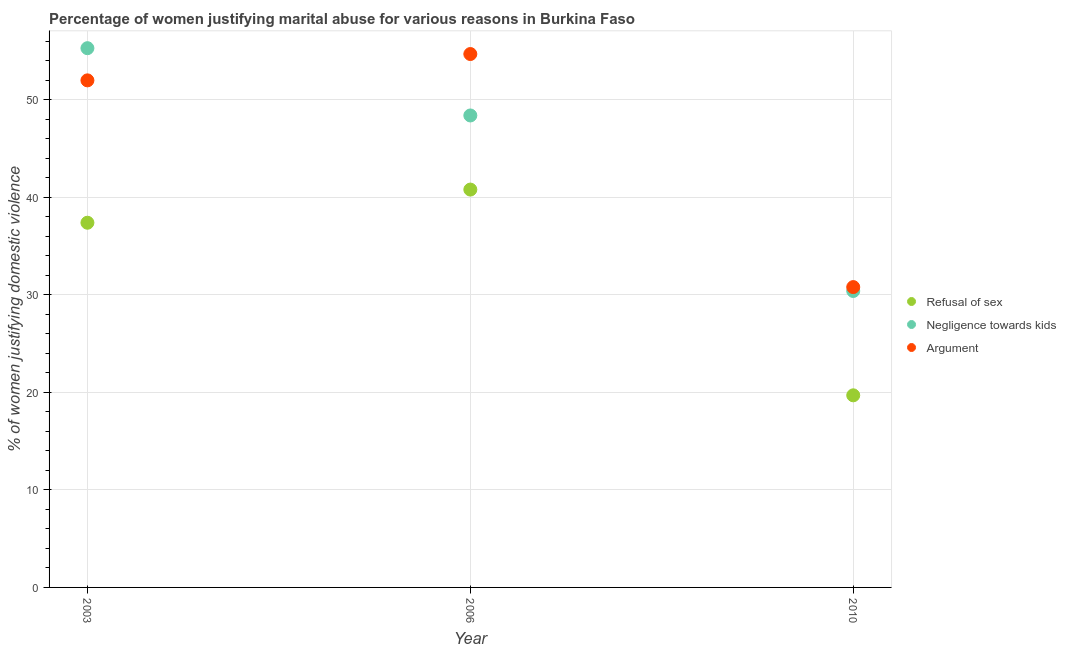How many different coloured dotlines are there?
Ensure brevity in your answer.  3. Is the number of dotlines equal to the number of legend labels?
Give a very brief answer. Yes. What is the percentage of women justifying domestic violence due to negligence towards kids in 2003?
Offer a terse response. 55.3. Across all years, what is the maximum percentage of women justifying domestic violence due to negligence towards kids?
Your answer should be very brief. 55.3. Across all years, what is the minimum percentage of women justifying domestic violence due to negligence towards kids?
Provide a short and direct response. 30.4. In which year was the percentage of women justifying domestic violence due to arguments maximum?
Provide a short and direct response. 2006. In which year was the percentage of women justifying domestic violence due to negligence towards kids minimum?
Ensure brevity in your answer.  2010. What is the total percentage of women justifying domestic violence due to negligence towards kids in the graph?
Your answer should be compact. 134.1. What is the difference between the percentage of women justifying domestic violence due to refusal of sex in 2006 and that in 2010?
Provide a short and direct response. 21.1. What is the difference between the percentage of women justifying domestic violence due to refusal of sex in 2003 and the percentage of women justifying domestic violence due to arguments in 2010?
Your answer should be compact. 6.6. What is the average percentage of women justifying domestic violence due to negligence towards kids per year?
Ensure brevity in your answer.  44.7. In the year 2006, what is the difference between the percentage of women justifying domestic violence due to negligence towards kids and percentage of women justifying domestic violence due to refusal of sex?
Make the answer very short. 7.6. What is the ratio of the percentage of women justifying domestic violence due to refusal of sex in 2006 to that in 2010?
Offer a terse response. 2.07. Is the percentage of women justifying domestic violence due to refusal of sex in 2006 less than that in 2010?
Keep it short and to the point. No. Is the difference between the percentage of women justifying domestic violence due to arguments in 2003 and 2010 greater than the difference between the percentage of women justifying domestic violence due to refusal of sex in 2003 and 2010?
Offer a very short reply. Yes. What is the difference between the highest and the second highest percentage of women justifying domestic violence due to refusal of sex?
Provide a short and direct response. 3.4. What is the difference between the highest and the lowest percentage of women justifying domestic violence due to refusal of sex?
Offer a terse response. 21.1. In how many years, is the percentage of women justifying domestic violence due to negligence towards kids greater than the average percentage of women justifying domestic violence due to negligence towards kids taken over all years?
Offer a very short reply. 2. Is the sum of the percentage of women justifying domestic violence due to arguments in 2006 and 2010 greater than the maximum percentage of women justifying domestic violence due to negligence towards kids across all years?
Give a very brief answer. Yes. Is it the case that in every year, the sum of the percentage of women justifying domestic violence due to refusal of sex and percentage of women justifying domestic violence due to negligence towards kids is greater than the percentage of women justifying domestic violence due to arguments?
Keep it short and to the point. Yes. Is the percentage of women justifying domestic violence due to arguments strictly greater than the percentage of women justifying domestic violence due to negligence towards kids over the years?
Make the answer very short. No. How many dotlines are there?
Make the answer very short. 3. How many years are there in the graph?
Your answer should be compact. 3. Are the values on the major ticks of Y-axis written in scientific E-notation?
Provide a short and direct response. No. Where does the legend appear in the graph?
Provide a short and direct response. Center right. What is the title of the graph?
Your answer should be very brief. Percentage of women justifying marital abuse for various reasons in Burkina Faso. Does "Poland" appear as one of the legend labels in the graph?
Your response must be concise. No. What is the label or title of the X-axis?
Your answer should be very brief. Year. What is the label or title of the Y-axis?
Give a very brief answer. % of women justifying domestic violence. What is the % of women justifying domestic violence in Refusal of sex in 2003?
Offer a very short reply. 37.4. What is the % of women justifying domestic violence in Negligence towards kids in 2003?
Your response must be concise. 55.3. What is the % of women justifying domestic violence of Refusal of sex in 2006?
Offer a very short reply. 40.8. What is the % of women justifying domestic violence in Negligence towards kids in 2006?
Make the answer very short. 48.4. What is the % of women justifying domestic violence of Argument in 2006?
Give a very brief answer. 54.7. What is the % of women justifying domestic violence in Refusal of sex in 2010?
Keep it short and to the point. 19.7. What is the % of women justifying domestic violence in Negligence towards kids in 2010?
Provide a short and direct response. 30.4. What is the % of women justifying domestic violence in Argument in 2010?
Your answer should be very brief. 30.8. Across all years, what is the maximum % of women justifying domestic violence of Refusal of sex?
Offer a very short reply. 40.8. Across all years, what is the maximum % of women justifying domestic violence in Negligence towards kids?
Your answer should be very brief. 55.3. Across all years, what is the maximum % of women justifying domestic violence of Argument?
Your response must be concise. 54.7. Across all years, what is the minimum % of women justifying domestic violence of Negligence towards kids?
Give a very brief answer. 30.4. Across all years, what is the minimum % of women justifying domestic violence of Argument?
Provide a succinct answer. 30.8. What is the total % of women justifying domestic violence of Refusal of sex in the graph?
Make the answer very short. 97.9. What is the total % of women justifying domestic violence in Negligence towards kids in the graph?
Provide a succinct answer. 134.1. What is the total % of women justifying domestic violence of Argument in the graph?
Make the answer very short. 137.5. What is the difference between the % of women justifying domestic violence in Negligence towards kids in 2003 and that in 2006?
Offer a terse response. 6.9. What is the difference between the % of women justifying domestic violence in Argument in 2003 and that in 2006?
Make the answer very short. -2.7. What is the difference between the % of women justifying domestic violence in Refusal of sex in 2003 and that in 2010?
Provide a succinct answer. 17.7. What is the difference between the % of women justifying domestic violence in Negligence towards kids in 2003 and that in 2010?
Make the answer very short. 24.9. What is the difference between the % of women justifying domestic violence of Argument in 2003 and that in 2010?
Your answer should be very brief. 21.2. What is the difference between the % of women justifying domestic violence of Refusal of sex in 2006 and that in 2010?
Give a very brief answer. 21.1. What is the difference between the % of women justifying domestic violence in Negligence towards kids in 2006 and that in 2010?
Offer a very short reply. 18. What is the difference between the % of women justifying domestic violence of Argument in 2006 and that in 2010?
Offer a very short reply. 23.9. What is the difference between the % of women justifying domestic violence in Refusal of sex in 2003 and the % of women justifying domestic violence in Argument in 2006?
Your answer should be compact. -17.3. What is the difference between the % of women justifying domestic violence of Negligence towards kids in 2003 and the % of women justifying domestic violence of Argument in 2006?
Your answer should be very brief. 0.6. What is the difference between the % of women justifying domestic violence in Refusal of sex in 2003 and the % of women justifying domestic violence in Negligence towards kids in 2010?
Offer a terse response. 7. What is the difference between the % of women justifying domestic violence in Refusal of sex in 2003 and the % of women justifying domestic violence in Argument in 2010?
Give a very brief answer. 6.6. What is the average % of women justifying domestic violence of Refusal of sex per year?
Provide a succinct answer. 32.63. What is the average % of women justifying domestic violence of Negligence towards kids per year?
Your answer should be compact. 44.7. What is the average % of women justifying domestic violence in Argument per year?
Ensure brevity in your answer.  45.83. In the year 2003, what is the difference between the % of women justifying domestic violence in Refusal of sex and % of women justifying domestic violence in Negligence towards kids?
Offer a terse response. -17.9. In the year 2003, what is the difference between the % of women justifying domestic violence of Refusal of sex and % of women justifying domestic violence of Argument?
Give a very brief answer. -14.6. In the year 2003, what is the difference between the % of women justifying domestic violence in Negligence towards kids and % of women justifying domestic violence in Argument?
Give a very brief answer. 3.3. In the year 2006, what is the difference between the % of women justifying domestic violence of Refusal of sex and % of women justifying domestic violence of Negligence towards kids?
Make the answer very short. -7.6. In the year 2006, what is the difference between the % of women justifying domestic violence in Refusal of sex and % of women justifying domestic violence in Argument?
Keep it short and to the point. -13.9. In the year 2006, what is the difference between the % of women justifying domestic violence in Negligence towards kids and % of women justifying domestic violence in Argument?
Give a very brief answer. -6.3. In the year 2010, what is the difference between the % of women justifying domestic violence in Negligence towards kids and % of women justifying domestic violence in Argument?
Provide a short and direct response. -0.4. What is the ratio of the % of women justifying domestic violence in Refusal of sex in 2003 to that in 2006?
Your answer should be very brief. 0.92. What is the ratio of the % of women justifying domestic violence in Negligence towards kids in 2003 to that in 2006?
Provide a succinct answer. 1.14. What is the ratio of the % of women justifying domestic violence of Argument in 2003 to that in 2006?
Make the answer very short. 0.95. What is the ratio of the % of women justifying domestic violence in Refusal of sex in 2003 to that in 2010?
Ensure brevity in your answer.  1.9. What is the ratio of the % of women justifying domestic violence of Negligence towards kids in 2003 to that in 2010?
Your answer should be compact. 1.82. What is the ratio of the % of women justifying domestic violence of Argument in 2003 to that in 2010?
Provide a succinct answer. 1.69. What is the ratio of the % of women justifying domestic violence in Refusal of sex in 2006 to that in 2010?
Keep it short and to the point. 2.07. What is the ratio of the % of women justifying domestic violence of Negligence towards kids in 2006 to that in 2010?
Your answer should be very brief. 1.59. What is the ratio of the % of women justifying domestic violence of Argument in 2006 to that in 2010?
Provide a short and direct response. 1.78. What is the difference between the highest and the second highest % of women justifying domestic violence of Negligence towards kids?
Make the answer very short. 6.9. What is the difference between the highest and the lowest % of women justifying domestic violence of Refusal of sex?
Your response must be concise. 21.1. What is the difference between the highest and the lowest % of women justifying domestic violence of Negligence towards kids?
Your response must be concise. 24.9. What is the difference between the highest and the lowest % of women justifying domestic violence of Argument?
Your response must be concise. 23.9. 